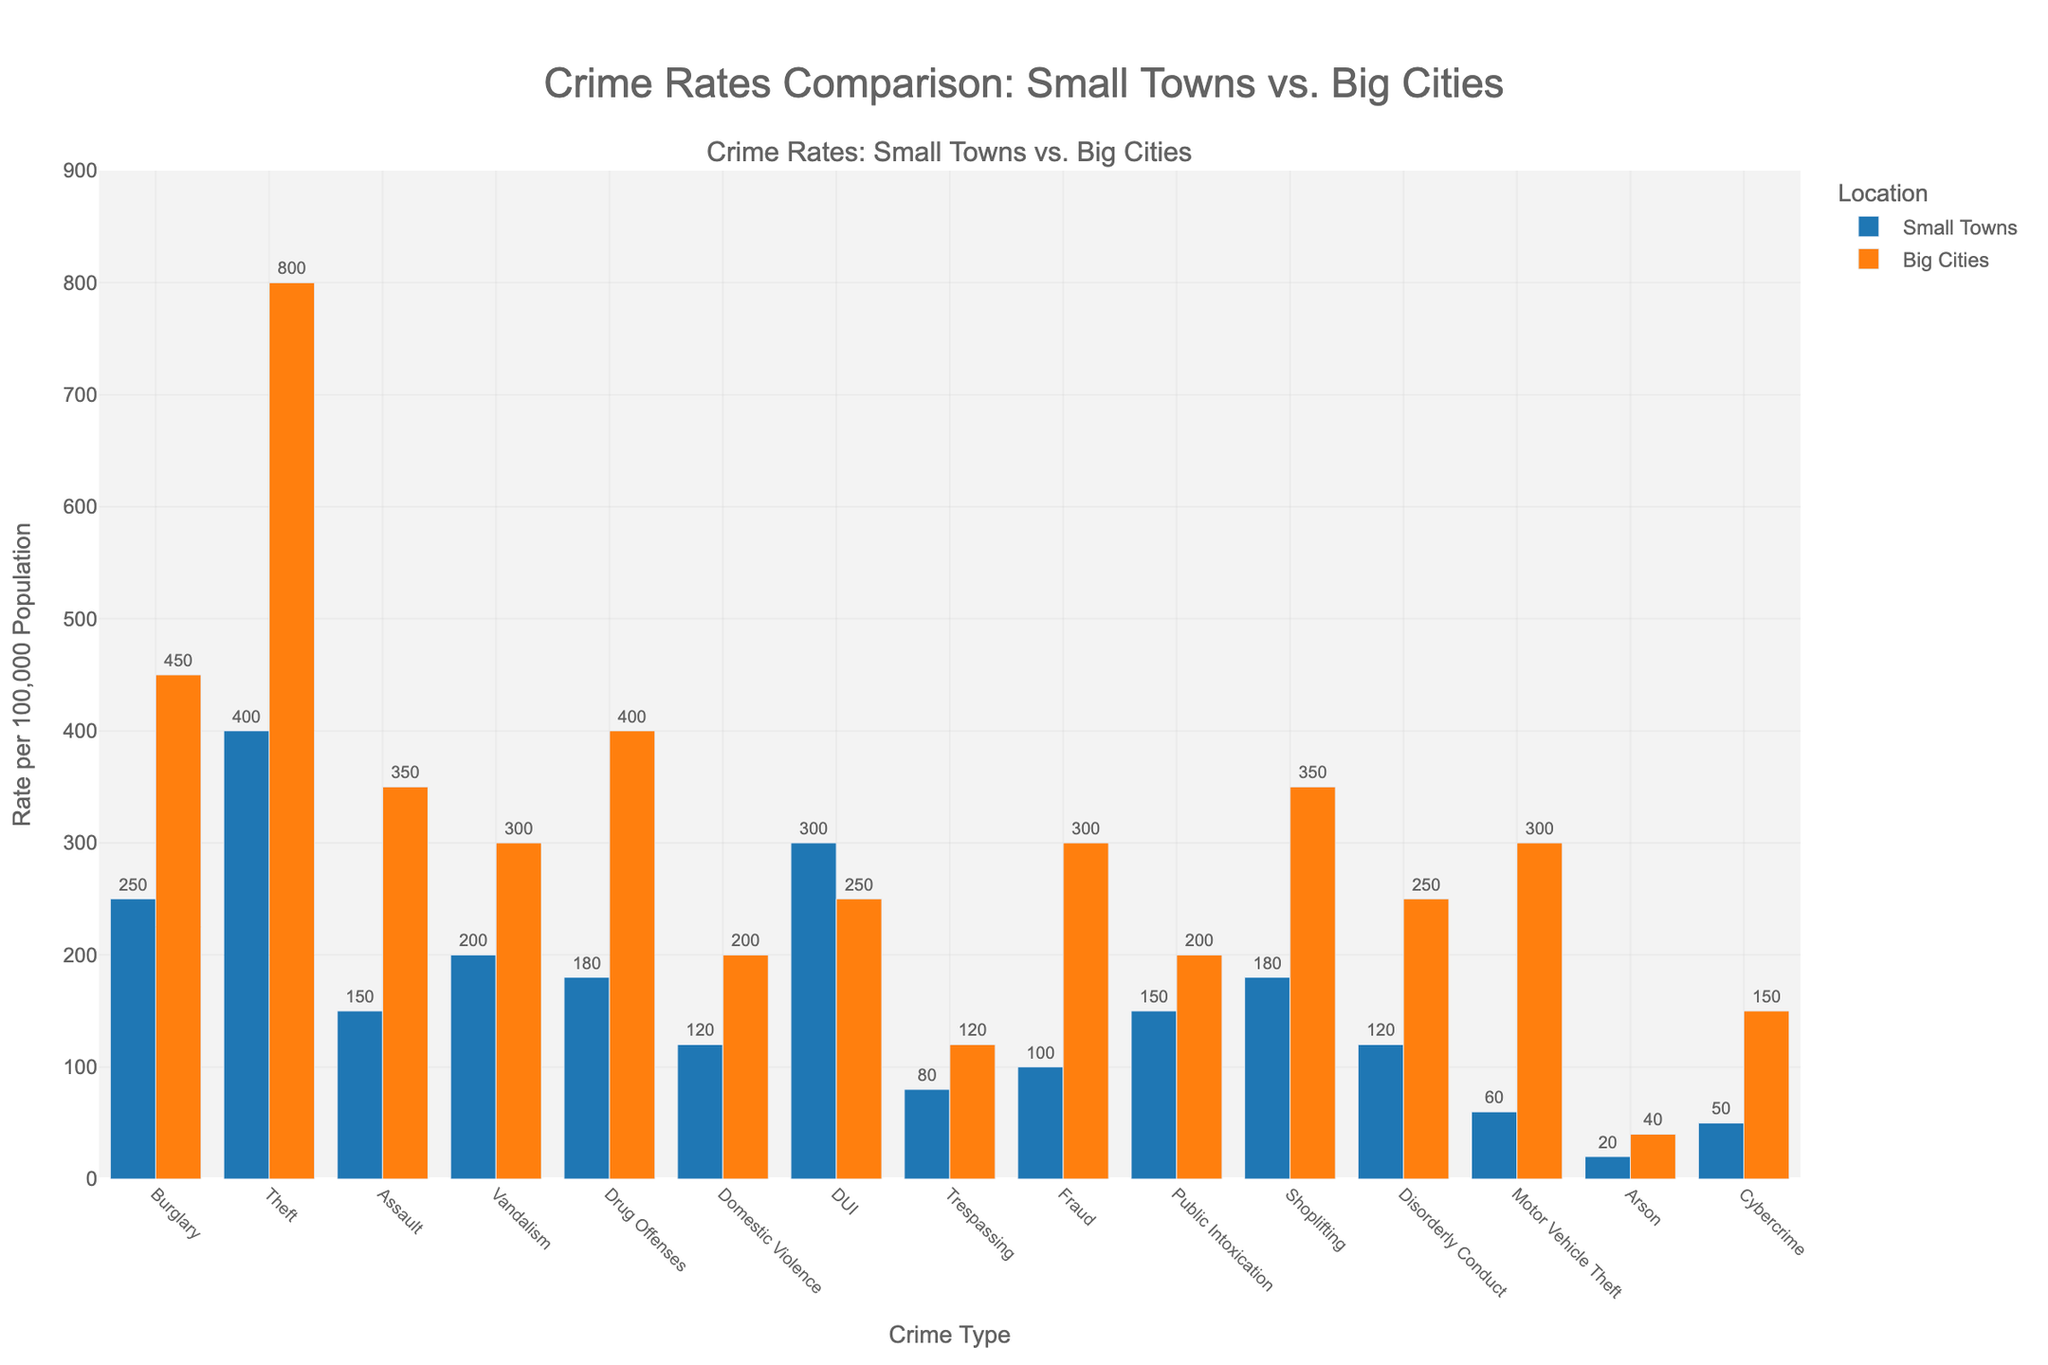Which crime type has the highest rate in small towns? Look at the heights of the blue bars for each crime type in the figure. Theft has the highest bar.
Answer: Theft Which crime type shows the largest difference in rates between small towns and big cities? Compare the differences in bar heights between blue and orange bars for each crime type. Theft shows the largest difference (800-400 = 400).
Answer: Theft What is the rate difference of DUI between small towns and big cities? Subtract the rate in big cities from the rate in small towns for DUI. 300 (small towns) - 250 (big cities) = 50.
Answer: 50 For which crime types is the rate higher in small towns compared to big cities? Check which blue bars are taller than orange bars. DUI, Trespassing, and Burglary have taller blue bars.
Answer: DUI, Trespassing, Burglary Is the average rate of assault in small towns and big cities higher or lower than the average rate of vandalism? Calculate averages: Assault rates are 150 (small towns) and 350 (big cities), so average is (150+350)/2=250. Vandalism rates are 200 (small towns) and 300 (big cities), so average is (200+300)/2=250. Both averages are equal.
Answer: Equal Which crime type shows a higher rate in big cities but not significantly higher compared to small towns? Look for orange bars slightly taller than blue bars. Vandalism has rates of 300 (big cities) vs 200 (small towns), which is a smaller difference compared to others.
Answer: Vandalism How does the rate of cybercrime in small towns compare to big cities? Compare the heights of blue and orange bars for Cybercrime. The orange bar (big cities) is significantly taller than the blue bar (small towns).
Answer: Much higher in big cities What is the combined rate for disorderly conduct in both small towns and big cities? Add the rates for disorderly conduct in small towns and big cities: 120 (small towns) + 250 (big cities) = 370.
Answer: 370 Which crime type has the smallest rate in small towns? Look for the shortest blue bar. Arson has the shortest bar at 20.
Answer: Arson Compare the rate of fraud between small towns and big cities. Which is higher and by how much? The rate of fraud is 100 (small towns) and 300 (big cities). Subtract the small towns' rate from the big cities' rate: 300 - 100 = 200.
Answer: Fraud is higher in big cities by 200 